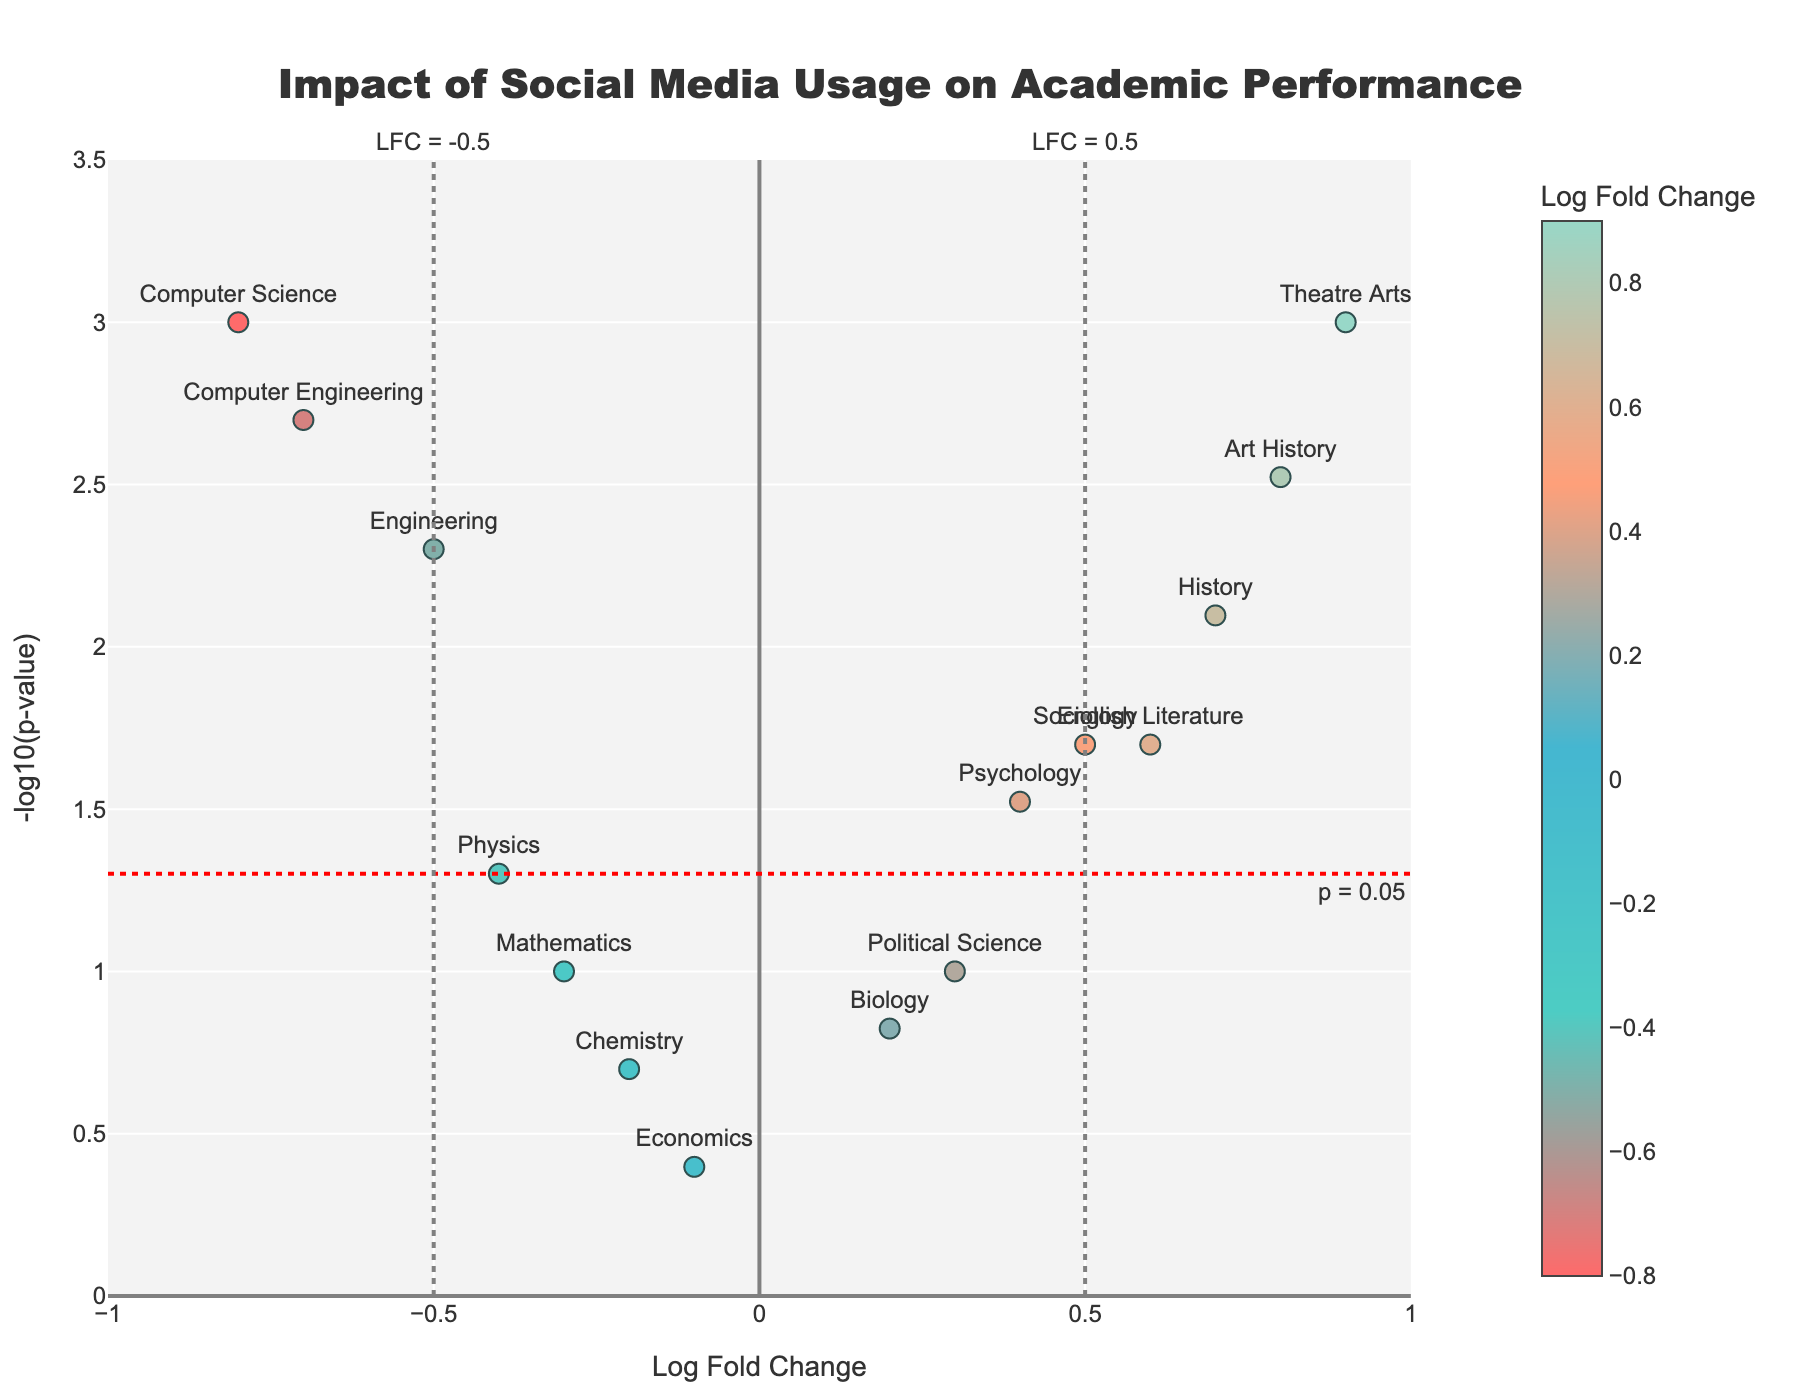What is the title of the figure? The title of the figure is displayed at the top. It reads "Impact of Social Media Usage on Academic Performance".
Answer: Impact of Social Media Usage on Academic Performance How is the x-axis labeled? The x-axis represents the Log Fold Change, which measures the change in academic performance due to social media usage. The label "Log Fold Change" is displayed along the x-axis.
Answer: Log Fold Change Which field has the most significant positive impact from social media usage? The most significant positive impact is identified by the data point with the highest y-value (smallest p-value) and a positive x-value. Theatre Arts has a Log Fold Change of 0.9 and a P-value of 0.001, making it the most significant.
Answer: Theatre Arts How many fields of study have a p-value less than 0.05? Identify all data points above the horizontal line y = -log10(0.05). These are the fields with p-values < 0.05. There are 8 such fields.
Answer: 8 Which field has the least significant negative impact from social media usage? The least significant negative impact is identified by the data point with the lowest y-value (highest p-value) among those with negative x-values. Economics has a Log Fold Change of -0.1 and a P-value of 0.4, making it the least significant negative impact.
Answer: Economics Compare the impact of social media usage on Computer Science and Theatre Arts. Which has a greater impact, and in which direction? Computer Science has a Log Fold Change of -0.8 (negative impact) and Theatre Arts has a Log Fold Change of 0.9 (positive impact). Theatre Arts has a greater positive impact compared to Computer Science's negative impact.
Answer: Theatre Arts, positive Which field has a Log Fold Change closest to zero? Find the data point where Log Fold Change (x-axis) is nearest to zero. Economics has a Log Fold Change of -0.1, which is the closest.
Answer: Economics Are there more fields with a positive or negative Log Fold Change? Count the number of data points with positive x-values (positive Log Fold Change) and those with negative x-values (negative Log Fold Change). There are 7 positive and 8 negative, so there are more fields with negative Log Fold Change.
Answer: Negative What is the p-value for History? Refer to the data point labeled "History" and check its hover text or position relative to the y-axis. History has a -log10(p-value) between 2 and 3, which means its p-value is 0.008.
Answer: 0.008 